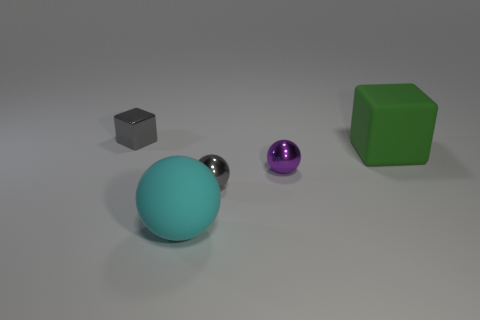Add 5 big blue metal objects. How many objects exist? 10 Subtract all spheres. How many objects are left? 2 Subtract all metal blocks. Subtract all tiny objects. How many objects are left? 1 Add 4 large rubber cubes. How many large rubber cubes are left? 5 Add 5 cyan matte objects. How many cyan matte objects exist? 6 Subtract 0 yellow cylinders. How many objects are left? 5 